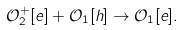<formula> <loc_0><loc_0><loc_500><loc_500>\mathcal { O } _ { 2 } ^ { + } [ e ] + \mathcal { O } _ { 1 } [ h ] \rightarrow \mathcal { O } _ { 1 } [ e ] .</formula> 